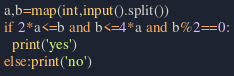Convert code to text. <code><loc_0><loc_0><loc_500><loc_500><_Python_>a,b=map(int,input().split())
if 2*a<=b and b<=4*a and b%2==0:
  print('yes')
else:print('no')</code> 